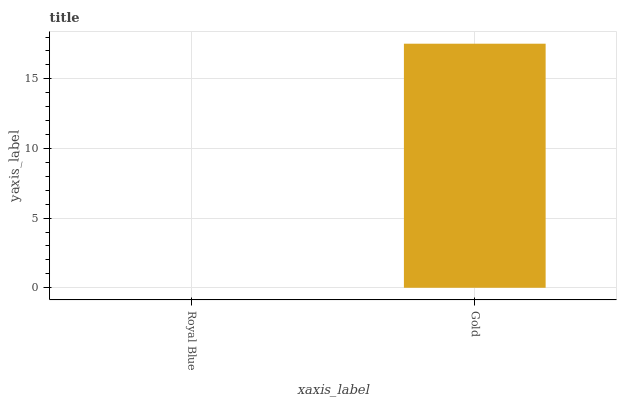Is Royal Blue the minimum?
Answer yes or no. Yes. Is Gold the maximum?
Answer yes or no. Yes. Is Gold the minimum?
Answer yes or no. No. Is Gold greater than Royal Blue?
Answer yes or no. Yes. Is Royal Blue less than Gold?
Answer yes or no. Yes. Is Royal Blue greater than Gold?
Answer yes or no. No. Is Gold less than Royal Blue?
Answer yes or no. No. Is Gold the high median?
Answer yes or no. Yes. Is Royal Blue the low median?
Answer yes or no. Yes. Is Royal Blue the high median?
Answer yes or no. No. Is Gold the low median?
Answer yes or no. No. 